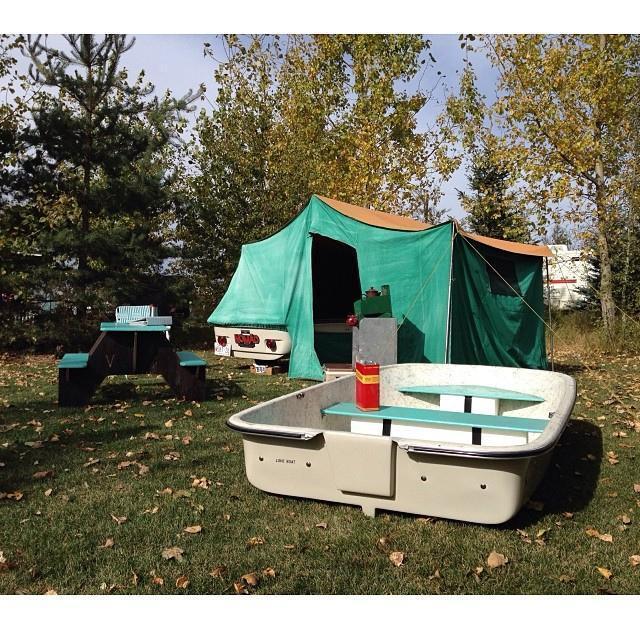Is "The boat is in front of the dining table." an appropriate description for the image?
Answer yes or no. Yes. Is "The boat contains the dining table." an appropriate description for the image?
Answer yes or no. No. Is this affirmation: "The dining table is on the boat." correct?
Answer yes or no. No. 